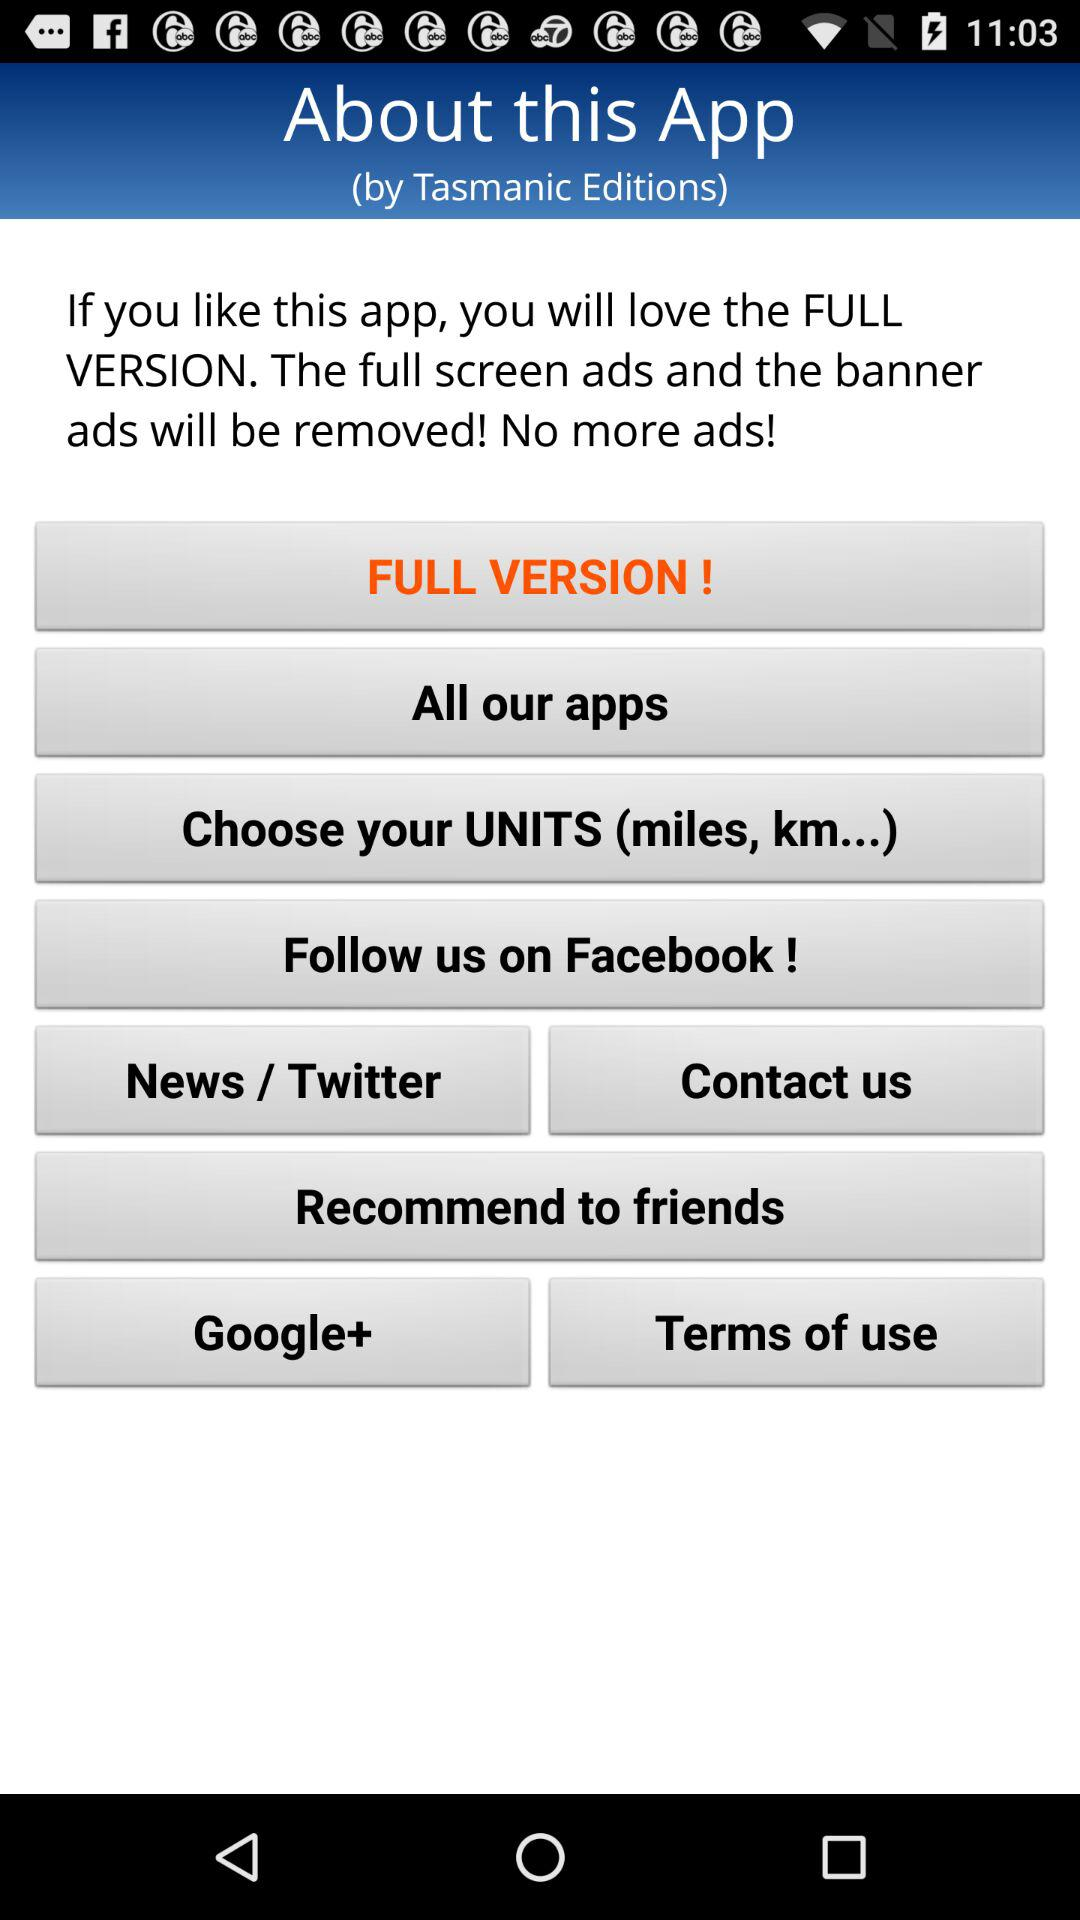On what social media platforms can we follow the application? You can follow the application on "Facebook". 